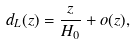<formula> <loc_0><loc_0><loc_500><loc_500>d _ { L } ( z ) = \frac { z } { H _ { 0 } } + o ( z ) ,</formula> 